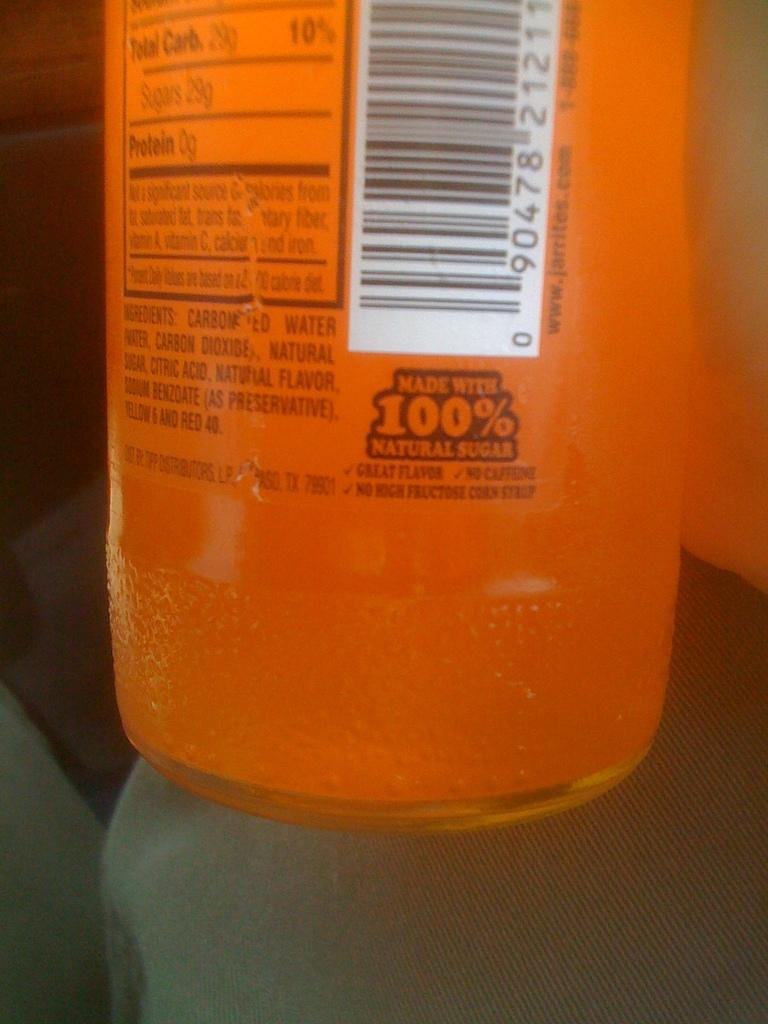<image>
Relay a brief, clear account of the picture shown. Orange drink that is made with 100% natural sugars. 